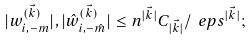Convert formula to latex. <formula><loc_0><loc_0><loc_500><loc_500>| w _ { i , - m } ^ { ( \vec { k } ) } | , | \hat { w } _ { i , - \hat { m } } ^ { ( \vec { k } ) } | \leq n ^ { | \vec { k } | } C _ { | \vec { k } | } / \ e p s ^ { | \vec { k } | } ;</formula> 